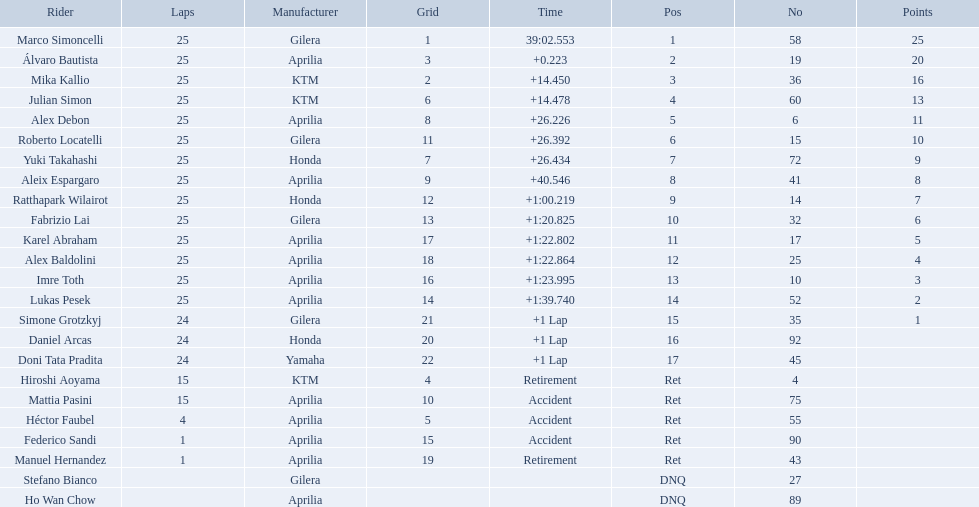How many laps did marco perform? 25. How many laps did hiroshi perform? 15. Which of these numbers are higher? 25. Who swam this number of laps? Marco Simoncelli. Can you give me this table as a dict? {'header': ['Rider', 'Laps', 'Manufacturer', 'Grid', 'Time', 'Pos', 'No', 'Points'], 'rows': [['Marco Simoncelli', '25', 'Gilera', '1', '39:02.553', '1', '58', '25'], ['Álvaro Bautista', '25', 'Aprilia', '3', '+0.223', '2', '19', '20'], ['Mika Kallio', '25', 'KTM', '2', '+14.450', '3', '36', '16'], ['Julian Simon', '25', 'KTM', '6', '+14.478', '4', '60', '13'], ['Alex Debon', '25', 'Aprilia', '8', '+26.226', '5', '6', '11'], ['Roberto Locatelli', '25', 'Gilera', '11', '+26.392', '6', '15', '10'], ['Yuki Takahashi', '25', 'Honda', '7', '+26.434', '7', '72', '9'], ['Aleix Espargaro', '25', 'Aprilia', '9', '+40.546', '8', '41', '8'], ['Ratthapark Wilairot', '25', 'Honda', '12', '+1:00.219', '9', '14', '7'], ['Fabrizio Lai', '25', 'Gilera', '13', '+1:20.825', '10', '32', '6'], ['Karel Abraham', '25', 'Aprilia', '17', '+1:22.802', '11', '17', '5'], ['Alex Baldolini', '25', 'Aprilia', '18', '+1:22.864', '12', '25', '4'], ['Imre Toth', '25', 'Aprilia', '16', '+1:23.995', '13', '10', '3'], ['Lukas Pesek', '25', 'Aprilia', '14', '+1:39.740', '14', '52', '2'], ['Simone Grotzkyj', '24', 'Gilera', '21', '+1 Lap', '15', '35', '1'], ['Daniel Arcas', '24', 'Honda', '20', '+1 Lap', '16', '92', ''], ['Doni Tata Pradita', '24', 'Yamaha', '22', '+1 Lap', '17', '45', ''], ['Hiroshi Aoyama', '15', 'KTM', '4', 'Retirement', 'Ret', '4', ''], ['Mattia Pasini', '15', 'Aprilia', '10', 'Accident', 'Ret', '75', ''], ['Héctor Faubel', '4', 'Aprilia', '5', 'Accident', 'Ret', '55', ''], ['Federico Sandi', '1', 'Aprilia', '15', 'Accident', 'Ret', '90', ''], ['Manuel Hernandez', '1', 'Aprilia', '19', 'Retirement', 'Ret', '43', ''], ['Stefano Bianco', '', 'Gilera', '', '', 'DNQ', '27', ''], ['Ho Wan Chow', '', 'Aprilia', '', '', 'DNQ', '89', '']]} How many laps did hiroshi aoyama perform? 15. How many laps did marco simoncelli perform? 25. Who performed more laps out of hiroshi aoyama and marco 
simoncelli? Marco Simoncelli. 